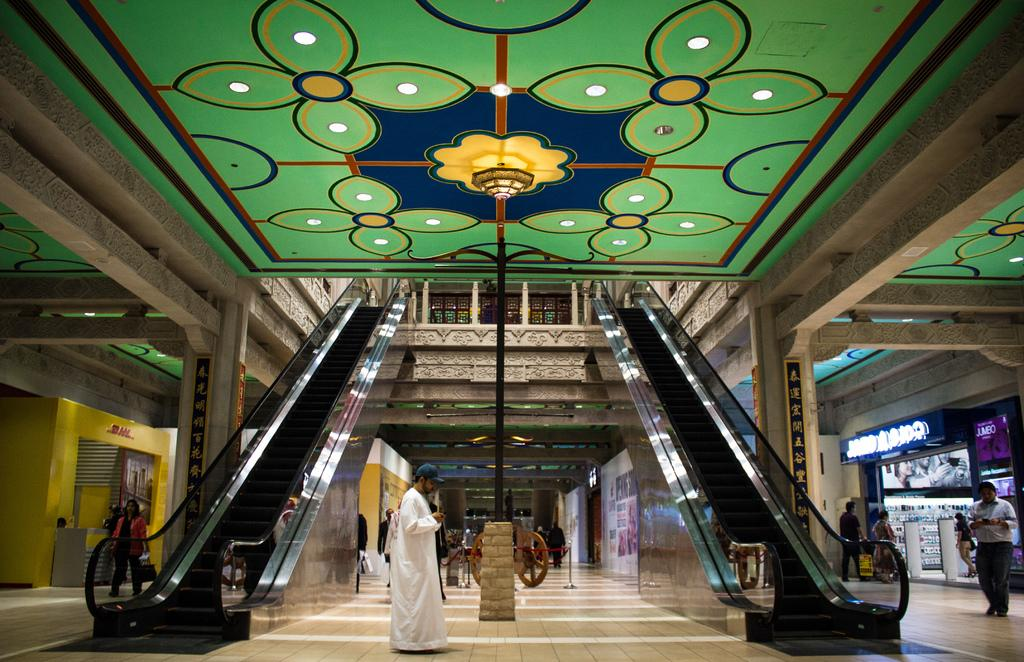Who or what can be seen in the image? There are people in the image. What type of objects are present that have a circular shape? There are wheels in the image. What type of transportation or movement aid is present in the image? There are escalators in the image. What type of objects are made of glass and can be seen in the image? There are glass objects in the image. What type of illumination is present in the image? There are lights in the image. Can you see any horses or squirrels in the image? No, there are no horses or squirrels present in the image. What type of woolen clothing can be seen on the people in the image? There is no woolen clothing visible on the people in the image. 